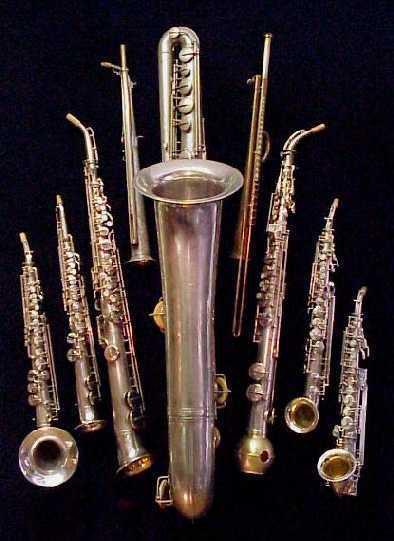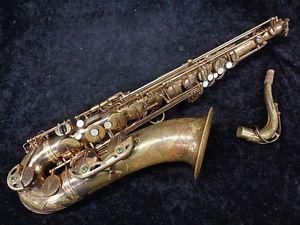The first image is the image on the left, the second image is the image on the right. Assess this claim about the two images: "Exactly two saxophones the same style, color, and size are positioned at the same angle, horizontal with their bells to the front.". Correct or not? Answer yes or no. No. The first image is the image on the left, the second image is the image on the right. Given the left and right images, does the statement "Each image shows one saxophone displayed nearly horizontally, with its bell downward, and all saxophones face the same direction." hold true? Answer yes or no. No. 